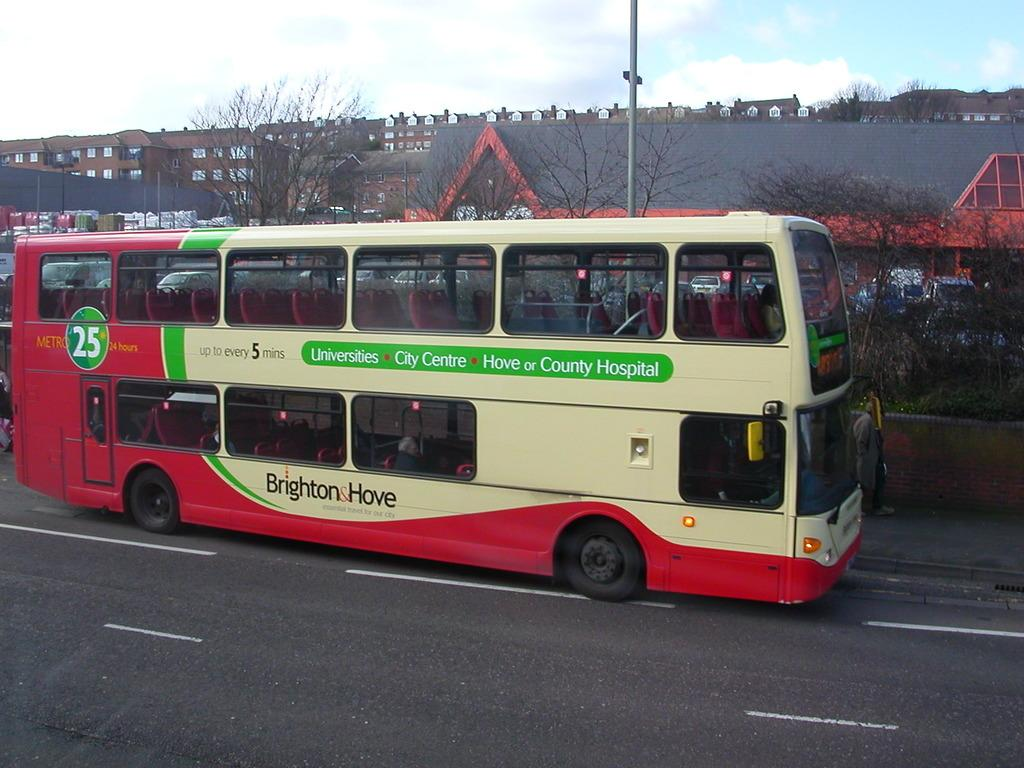Provide a one-sentence caption for the provided image. Double decker bus that says "Up to every 5 mins" on the side. 